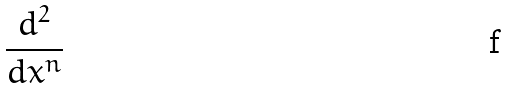<formula> <loc_0><loc_0><loc_500><loc_500>\frac { d ^ { 2 } } { d x ^ { n } }</formula> 